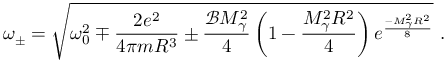<formula> <loc_0><loc_0><loc_500><loc_500>\omega _ { \pm } = \sqrt { \omega _ { 0 } ^ { 2 } \mp \frac { 2 e ^ { 2 } } { 4 \pi m R ^ { 3 } } \pm \frac { \mathcal { B } M _ { \gamma } ^ { 2 } } { 4 } \left ( 1 - \frac { M _ { \gamma } ^ { 2 } R ^ { 2 } } { 4 } \right ) e ^ { \frac { - M _ { \gamma } ^ { 2 } R ^ { 2 } } { 8 } } } \ .</formula> 